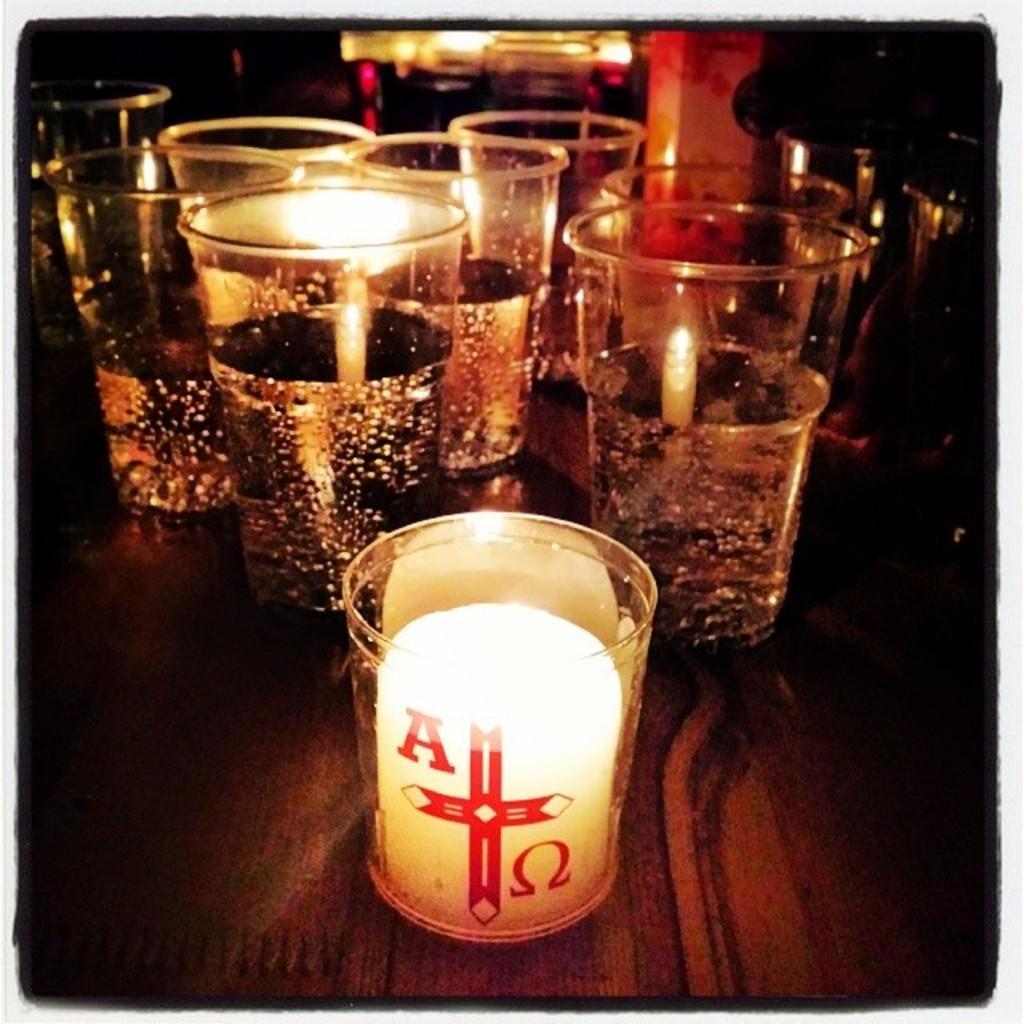Could you give a brief overview of what you see in this image? In this image I can see many glasses. These glasses are on the brown color surface. I can see there is a blurred background. 